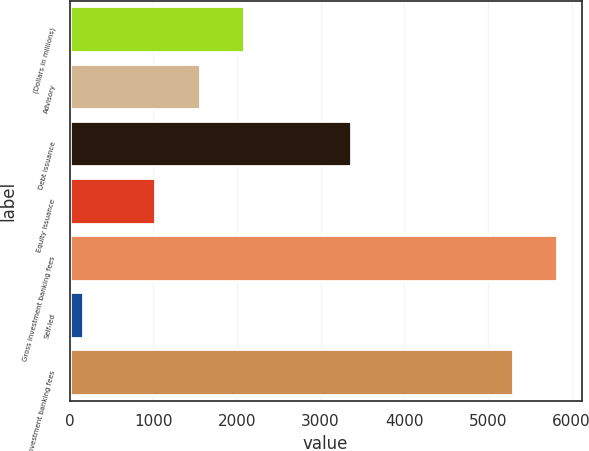Convert chart. <chart><loc_0><loc_0><loc_500><loc_500><bar_chart><fcel>(Dollars in millions)<fcel>Advisory<fcel>Debt issuance<fcel>Equity issuance<fcel>Gross investment banking fees<fcel>Self-led<fcel>Total investment banking fees<nl><fcel>2085.8<fcel>1555.9<fcel>3362<fcel>1026<fcel>5828.9<fcel>155<fcel>5299<nl></chart> 